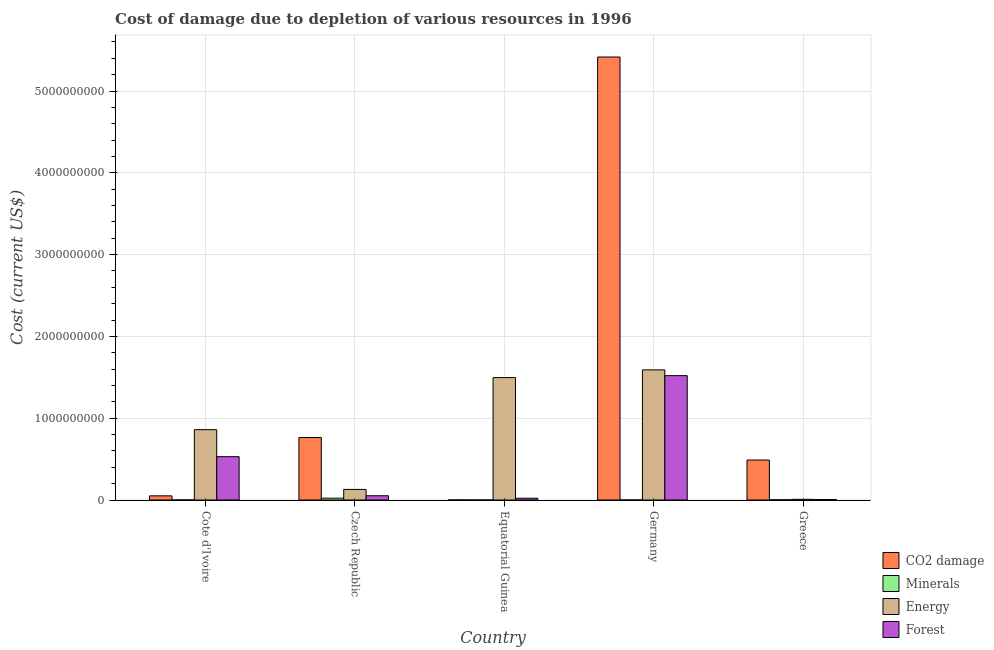Are the number of bars per tick equal to the number of legend labels?
Your response must be concise. Yes. How many bars are there on the 4th tick from the left?
Make the answer very short. 4. How many bars are there on the 1st tick from the right?
Your answer should be very brief. 4. What is the label of the 1st group of bars from the left?
Your answer should be compact. Cote d'Ivoire. In how many cases, is the number of bars for a given country not equal to the number of legend labels?
Your response must be concise. 0. What is the cost of damage due to depletion of minerals in Equatorial Guinea?
Provide a succinct answer. 5.43e+04. Across all countries, what is the maximum cost of damage due to depletion of forests?
Offer a terse response. 1.52e+09. Across all countries, what is the minimum cost of damage due to depletion of coal?
Keep it short and to the point. 7.14e+05. In which country was the cost of damage due to depletion of coal minimum?
Keep it short and to the point. Equatorial Guinea. What is the total cost of damage due to depletion of minerals in the graph?
Keep it short and to the point. 2.57e+07. What is the difference between the cost of damage due to depletion of minerals in Cote d'Ivoire and that in Greece?
Make the answer very short. -1.79e+06. What is the difference between the cost of damage due to depletion of forests in Cote d'Ivoire and the cost of damage due to depletion of minerals in Germany?
Your answer should be compact. 5.30e+08. What is the average cost of damage due to depletion of minerals per country?
Your response must be concise. 5.14e+06. What is the difference between the cost of damage due to depletion of energy and cost of damage due to depletion of forests in Cote d'Ivoire?
Provide a short and direct response. 3.30e+08. What is the ratio of the cost of damage due to depletion of forests in Cote d'Ivoire to that in Equatorial Guinea?
Give a very brief answer. 24.6. Is the cost of damage due to depletion of energy in Cote d'Ivoire less than that in Czech Republic?
Give a very brief answer. No. What is the difference between the highest and the second highest cost of damage due to depletion of energy?
Make the answer very short. 9.44e+07. What is the difference between the highest and the lowest cost of damage due to depletion of energy?
Give a very brief answer. 1.58e+09. Is the sum of the cost of damage due to depletion of energy in Czech Republic and Greece greater than the maximum cost of damage due to depletion of forests across all countries?
Offer a terse response. No. What does the 2nd bar from the left in Cote d'Ivoire represents?
Provide a short and direct response. Minerals. What does the 1st bar from the right in Equatorial Guinea represents?
Your answer should be compact. Forest. Is it the case that in every country, the sum of the cost of damage due to depletion of coal and cost of damage due to depletion of minerals is greater than the cost of damage due to depletion of energy?
Give a very brief answer. No. How many countries are there in the graph?
Offer a terse response. 5. What is the difference between two consecutive major ticks on the Y-axis?
Your answer should be very brief. 1.00e+09. Does the graph contain grids?
Your answer should be compact. Yes. How are the legend labels stacked?
Provide a short and direct response. Vertical. What is the title of the graph?
Offer a very short reply. Cost of damage due to depletion of various resources in 1996 . What is the label or title of the Y-axis?
Your answer should be very brief. Cost (current US$). What is the Cost (current US$) in CO2 damage in Cote d'Ivoire?
Keep it short and to the point. 5.10e+07. What is the Cost (current US$) in Minerals in Cote d'Ivoire?
Give a very brief answer. 7.40e+05. What is the Cost (current US$) in Energy in Cote d'Ivoire?
Offer a very short reply. 8.60e+08. What is the Cost (current US$) in Forest in Cote d'Ivoire?
Make the answer very short. 5.30e+08. What is the Cost (current US$) in CO2 damage in Czech Republic?
Your answer should be compact. 7.64e+08. What is the Cost (current US$) of Minerals in Czech Republic?
Keep it short and to the point. 2.23e+07. What is the Cost (current US$) of Energy in Czech Republic?
Your answer should be very brief. 1.29e+08. What is the Cost (current US$) of Forest in Czech Republic?
Your response must be concise. 5.21e+07. What is the Cost (current US$) of CO2 damage in Equatorial Guinea?
Keep it short and to the point. 7.14e+05. What is the Cost (current US$) in Minerals in Equatorial Guinea?
Make the answer very short. 5.43e+04. What is the Cost (current US$) in Energy in Equatorial Guinea?
Offer a very short reply. 1.50e+09. What is the Cost (current US$) of Forest in Equatorial Guinea?
Provide a succinct answer. 2.15e+07. What is the Cost (current US$) of CO2 damage in Germany?
Your answer should be very brief. 5.42e+09. What is the Cost (current US$) in Minerals in Germany?
Your answer should be compact. 7.40e+04. What is the Cost (current US$) of Energy in Germany?
Your answer should be very brief. 1.59e+09. What is the Cost (current US$) of Forest in Germany?
Give a very brief answer. 1.52e+09. What is the Cost (current US$) in CO2 damage in Greece?
Keep it short and to the point. 4.89e+08. What is the Cost (current US$) in Minerals in Greece?
Provide a succinct answer. 2.53e+06. What is the Cost (current US$) of Energy in Greece?
Keep it short and to the point. 8.16e+06. What is the Cost (current US$) in Forest in Greece?
Ensure brevity in your answer.  5.20e+06. Across all countries, what is the maximum Cost (current US$) of CO2 damage?
Your answer should be very brief. 5.42e+09. Across all countries, what is the maximum Cost (current US$) in Minerals?
Offer a terse response. 2.23e+07. Across all countries, what is the maximum Cost (current US$) in Energy?
Your answer should be very brief. 1.59e+09. Across all countries, what is the maximum Cost (current US$) of Forest?
Provide a succinct answer. 1.52e+09. Across all countries, what is the minimum Cost (current US$) of CO2 damage?
Ensure brevity in your answer.  7.14e+05. Across all countries, what is the minimum Cost (current US$) in Minerals?
Your response must be concise. 5.43e+04. Across all countries, what is the minimum Cost (current US$) of Energy?
Make the answer very short. 8.16e+06. Across all countries, what is the minimum Cost (current US$) of Forest?
Provide a short and direct response. 5.20e+06. What is the total Cost (current US$) in CO2 damage in the graph?
Keep it short and to the point. 6.72e+09. What is the total Cost (current US$) in Minerals in the graph?
Offer a very short reply. 2.57e+07. What is the total Cost (current US$) of Energy in the graph?
Provide a short and direct response. 4.09e+09. What is the total Cost (current US$) of Forest in the graph?
Your response must be concise. 2.13e+09. What is the difference between the Cost (current US$) of CO2 damage in Cote d'Ivoire and that in Czech Republic?
Give a very brief answer. -7.13e+08. What is the difference between the Cost (current US$) in Minerals in Cote d'Ivoire and that in Czech Republic?
Your response must be concise. -2.16e+07. What is the difference between the Cost (current US$) in Energy in Cote d'Ivoire and that in Czech Republic?
Give a very brief answer. 7.31e+08. What is the difference between the Cost (current US$) in Forest in Cote d'Ivoire and that in Czech Republic?
Your response must be concise. 4.78e+08. What is the difference between the Cost (current US$) in CO2 damage in Cote d'Ivoire and that in Equatorial Guinea?
Ensure brevity in your answer.  5.03e+07. What is the difference between the Cost (current US$) in Minerals in Cote d'Ivoire and that in Equatorial Guinea?
Your answer should be compact. 6.86e+05. What is the difference between the Cost (current US$) of Energy in Cote d'Ivoire and that in Equatorial Guinea?
Your answer should be very brief. -6.37e+08. What is the difference between the Cost (current US$) in Forest in Cote d'Ivoire and that in Equatorial Guinea?
Give a very brief answer. 5.08e+08. What is the difference between the Cost (current US$) of CO2 damage in Cote d'Ivoire and that in Germany?
Keep it short and to the point. -5.36e+09. What is the difference between the Cost (current US$) of Minerals in Cote d'Ivoire and that in Germany?
Offer a terse response. 6.66e+05. What is the difference between the Cost (current US$) in Energy in Cote d'Ivoire and that in Germany?
Give a very brief answer. -7.31e+08. What is the difference between the Cost (current US$) in Forest in Cote d'Ivoire and that in Germany?
Your answer should be compact. -9.91e+08. What is the difference between the Cost (current US$) in CO2 damage in Cote d'Ivoire and that in Greece?
Ensure brevity in your answer.  -4.37e+08. What is the difference between the Cost (current US$) of Minerals in Cote d'Ivoire and that in Greece?
Keep it short and to the point. -1.79e+06. What is the difference between the Cost (current US$) in Energy in Cote d'Ivoire and that in Greece?
Provide a succinct answer. 8.52e+08. What is the difference between the Cost (current US$) of Forest in Cote d'Ivoire and that in Greece?
Offer a very short reply. 5.24e+08. What is the difference between the Cost (current US$) of CO2 damage in Czech Republic and that in Equatorial Guinea?
Make the answer very short. 7.63e+08. What is the difference between the Cost (current US$) in Minerals in Czech Republic and that in Equatorial Guinea?
Ensure brevity in your answer.  2.23e+07. What is the difference between the Cost (current US$) of Energy in Czech Republic and that in Equatorial Guinea?
Provide a succinct answer. -1.37e+09. What is the difference between the Cost (current US$) of Forest in Czech Republic and that in Equatorial Guinea?
Make the answer very short. 3.06e+07. What is the difference between the Cost (current US$) of CO2 damage in Czech Republic and that in Germany?
Offer a very short reply. -4.65e+09. What is the difference between the Cost (current US$) in Minerals in Czech Republic and that in Germany?
Give a very brief answer. 2.22e+07. What is the difference between the Cost (current US$) of Energy in Czech Republic and that in Germany?
Provide a short and direct response. -1.46e+09. What is the difference between the Cost (current US$) in Forest in Czech Republic and that in Germany?
Offer a terse response. -1.47e+09. What is the difference between the Cost (current US$) in CO2 damage in Czech Republic and that in Greece?
Offer a terse response. 2.75e+08. What is the difference between the Cost (current US$) of Minerals in Czech Republic and that in Greece?
Offer a very short reply. 1.98e+07. What is the difference between the Cost (current US$) of Energy in Czech Republic and that in Greece?
Offer a terse response. 1.21e+08. What is the difference between the Cost (current US$) in Forest in Czech Republic and that in Greece?
Ensure brevity in your answer.  4.69e+07. What is the difference between the Cost (current US$) in CO2 damage in Equatorial Guinea and that in Germany?
Keep it short and to the point. -5.42e+09. What is the difference between the Cost (current US$) of Minerals in Equatorial Guinea and that in Germany?
Ensure brevity in your answer.  -1.97e+04. What is the difference between the Cost (current US$) of Energy in Equatorial Guinea and that in Germany?
Give a very brief answer. -9.44e+07. What is the difference between the Cost (current US$) in Forest in Equatorial Guinea and that in Germany?
Make the answer very short. -1.50e+09. What is the difference between the Cost (current US$) in CO2 damage in Equatorial Guinea and that in Greece?
Provide a succinct answer. -4.88e+08. What is the difference between the Cost (current US$) of Minerals in Equatorial Guinea and that in Greece?
Provide a short and direct response. -2.48e+06. What is the difference between the Cost (current US$) of Energy in Equatorial Guinea and that in Greece?
Provide a succinct answer. 1.49e+09. What is the difference between the Cost (current US$) of Forest in Equatorial Guinea and that in Greece?
Offer a very short reply. 1.63e+07. What is the difference between the Cost (current US$) in CO2 damage in Germany and that in Greece?
Offer a very short reply. 4.93e+09. What is the difference between the Cost (current US$) in Minerals in Germany and that in Greece?
Keep it short and to the point. -2.46e+06. What is the difference between the Cost (current US$) in Energy in Germany and that in Greece?
Ensure brevity in your answer.  1.58e+09. What is the difference between the Cost (current US$) in Forest in Germany and that in Greece?
Ensure brevity in your answer.  1.52e+09. What is the difference between the Cost (current US$) of CO2 damage in Cote d'Ivoire and the Cost (current US$) of Minerals in Czech Republic?
Your answer should be compact. 2.87e+07. What is the difference between the Cost (current US$) in CO2 damage in Cote d'Ivoire and the Cost (current US$) in Energy in Czech Republic?
Your answer should be very brief. -7.84e+07. What is the difference between the Cost (current US$) in CO2 damage in Cote d'Ivoire and the Cost (current US$) in Forest in Czech Republic?
Provide a succinct answer. -1.10e+06. What is the difference between the Cost (current US$) of Minerals in Cote d'Ivoire and the Cost (current US$) of Energy in Czech Republic?
Your answer should be very brief. -1.29e+08. What is the difference between the Cost (current US$) in Minerals in Cote d'Ivoire and the Cost (current US$) in Forest in Czech Republic?
Your answer should be very brief. -5.14e+07. What is the difference between the Cost (current US$) of Energy in Cote d'Ivoire and the Cost (current US$) of Forest in Czech Republic?
Offer a terse response. 8.08e+08. What is the difference between the Cost (current US$) in CO2 damage in Cote d'Ivoire and the Cost (current US$) in Minerals in Equatorial Guinea?
Keep it short and to the point. 5.10e+07. What is the difference between the Cost (current US$) of CO2 damage in Cote d'Ivoire and the Cost (current US$) of Energy in Equatorial Guinea?
Ensure brevity in your answer.  -1.45e+09. What is the difference between the Cost (current US$) of CO2 damage in Cote d'Ivoire and the Cost (current US$) of Forest in Equatorial Guinea?
Your response must be concise. 2.95e+07. What is the difference between the Cost (current US$) in Minerals in Cote d'Ivoire and the Cost (current US$) in Energy in Equatorial Guinea?
Ensure brevity in your answer.  -1.50e+09. What is the difference between the Cost (current US$) of Minerals in Cote d'Ivoire and the Cost (current US$) of Forest in Equatorial Guinea?
Your answer should be compact. -2.08e+07. What is the difference between the Cost (current US$) in Energy in Cote d'Ivoire and the Cost (current US$) in Forest in Equatorial Guinea?
Your answer should be compact. 8.39e+08. What is the difference between the Cost (current US$) in CO2 damage in Cote d'Ivoire and the Cost (current US$) in Minerals in Germany?
Make the answer very short. 5.09e+07. What is the difference between the Cost (current US$) in CO2 damage in Cote d'Ivoire and the Cost (current US$) in Energy in Germany?
Keep it short and to the point. -1.54e+09. What is the difference between the Cost (current US$) of CO2 damage in Cote d'Ivoire and the Cost (current US$) of Forest in Germany?
Your answer should be very brief. -1.47e+09. What is the difference between the Cost (current US$) in Minerals in Cote d'Ivoire and the Cost (current US$) in Energy in Germany?
Offer a terse response. -1.59e+09. What is the difference between the Cost (current US$) in Minerals in Cote d'Ivoire and the Cost (current US$) in Forest in Germany?
Make the answer very short. -1.52e+09. What is the difference between the Cost (current US$) in Energy in Cote d'Ivoire and the Cost (current US$) in Forest in Germany?
Your answer should be compact. -6.60e+08. What is the difference between the Cost (current US$) in CO2 damage in Cote d'Ivoire and the Cost (current US$) in Minerals in Greece?
Your answer should be very brief. 4.85e+07. What is the difference between the Cost (current US$) in CO2 damage in Cote d'Ivoire and the Cost (current US$) in Energy in Greece?
Offer a very short reply. 4.29e+07. What is the difference between the Cost (current US$) of CO2 damage in Cote d'Ivoire and the Cost (current US$) of Forest in Greece?
Your answer should be compact. 4.58e+07. What is the difference between the Cost (current US$) of Minerals in Cote d'Ivoire and the Cost (current US$) of Energy in Greece?
Provide a short and direct response. -7.42e+06. What is the difference between the Cost (current US$) of Minerals in Cote d'Ivoire and the Cost (current US$) of Forest in Greece?
Keep it short and to the point. -4.46e+06. What is the difference between the Cost (current US$) in Energy in Cote d'Ivoire and the Cost (current US$) in Forest in Greece?
Provide a succinct answer. 8.55e+08. What is the difference between the Cost (current US$) of CO2 damage in Czech Republic and the Cost (current US$) of Minerals in Equatorial Guinea?
Make the answer very short. 7.64e+08. What is the difference between the Cost (current US$) in CO2 damage in Czech Republic and the Cost (current US$) in Energy in Equatorial Guinea?
Offer a terse response. -7.33e+08. What is the difference between the Cost (current US$) in CO2 damage in Czech Republic and the Cost (current US$) in Forest in Equatorial Guinea?
Offer a terse response. 7.42e+08. What is the difference between the Cost (current US$) in Minerals in Czech Republic and the Cost (current US$) in Energy in Equatorial Guinea?
Give a very brief answer. -1.47e+09. What is the difference between the Cost (current US$) in Minerals in Czech Republic and the Cost (current US$) in Forest in Equatorial Guinea?
Ensure brevity in your answer.  7.80e+05. What is the difference between the Cost (current US$) of Energy in Czech Republic and the Cost (current US$) of Forest in Equatorial Guinea?
Offer a very short reply. 1.08e+08. What is the difference between the Cost (current US$) in CO2 damage in Czech Republic and the Cost (current US$) in Minerals in Germany?
Provide a succinct answer. 7.64e+08. What is the difference between the Cost (current US$) of CO2 damage in Czech Republic and the Cost (current US$) of Energy in Germany?
Provide a succinct answer. -8.27e+08. What is the difference between the Cost (current US$) of CO2 damage in Czech Republic and the Cost (current US$) of Forest in Germany?
Give a very brief answer. -7.56e+08. What is the difference between the Cost (current US$) in Minerals in Czech Republic and the Cost (current US$) in Energy in Germany?
Offer a terse response. -1.57e+09. What is the difference between the Cost (current US$) in Minerals in Czech Republic and the Cost (current US$) in Forest in Germany?
Keep it short and to the point. -1.50e+09. What is the difference between the Cost (current US$) of Energy in Czech Republic and the Cost (current US$) of Forest in Germany?
Provide a short and direct response. -1.39e+09. What is the difference between the Cost (current US$) of CO2 damage in Czech Republic and the Cost (current US$) of Minerals in Greece?
Ensure brevity in your answer.  7.61e+08. What is the difference between the Cost (current US$) of CO2 damage in Czech Republic and the Cost (current US$) of Energy in Greece?
Make the answer very short. 7.56e+08. What is the difference between the Cost (current US$) in CO2 damage in Czech Republic and the Cost (current US$) in Forest in Greece?
Make the answer very short. 7.59e+08. What is the difference between the Cost (current US$) in Minerals in Czech Republic and the Cost (current US$) in Energy in Greece?
Your response must be concise. 1.42e+07. What is the difference between the Cost (current US$) of Minerals in Czech Republic and the Cost (current US$) of Forest in Greece?
Make the answer very short. 1.71e+07. What is the difference between the Cost (current US$) in Energy in Czech Republic and the Cost (current US$) in Forest in Greece?
Your response must be concise. 1.24e+08. What is the difference between the Cost (current US$) of CO2 damage in Equatorial Guinea and the Cost (current US$) of Minerals in Germany?
Your response must be concise. 6.40e+05. What is the difference between the Cost (current US$) in CO2 damage in Equatorial Guinea and the Cost (current US$) in Energy in Germany?
Your answer should be compact. -1.59e+09. What is the difference between the Cost (current US$) in CO2 damage in Equatorial Guinea and the Cost (current US$) in Forest in Germany?
Make the answer very short. -1.52e+09. What is the difference between the Cost (current US$) of Minerals in Equatorial Guinea and the Cost (current US$) of Energy in Germany?
Make the answer very short. -1.59e+09. What is the difference between the Cost (current US$) in Minerals in Equatorial Guinea and the Cost (current US$) in Forest in Germany?
Your answer should be very brief. -1.52e+09. What is the difference between the Cost (current US$) in Energy in Equatorial Guinea and the Cost (current US$) in Forest in Germany?
Provide a short and direct response. -2.37e+07. What is the difference between the Cost (current US$) of CO2 damage in Equatorial Guinea and the Cost (current US$) of Minerals in Greece?
Offer a very short reply. -1.82e+06. What is the difference between the Cost (current US$) in CO2 damage in Equatorial Guinea and the Cost (current US$) in Energy in Greece?
Give a very brief answer. -7.45e+06. What is the difference between the Cost (current US$) in CO2 damage in Equatorial Guinea and the Cost (current US$) in Forest in Greece?
Your response must be concise. -4.48e+06. What is the difference between the Cost (current US$) of Minerals in Equatorial Guinea and the Cost (current US$) of Energy in Greece?
Give a very brief answer. -8.11e+06. What is the difference between the Cost (current US$) in Minerals in Equatorial Guinea and the Cost (current US$) in Forest in Greece?
Offer a terse response. -5.14e+06. What is the difference between the Cost (current US$) in Energy in Equatorial Guinea and the Cost (current US$) in Forest in Greece?
Provide a short and direct response. 1.49e+09. What is the difference between the Cost (current US$) in CO2 damage in Germany and the Cost (current US$) in Minerals in Greece?
Give a very brief answer. 5.41e+09. What is the difference between the Cost (current US$) of CO2 damage in Germany and the Cost (current US$) of Energy in Greece?
Make the answer very short. 5.41e+09. What is the difference between the Cost (current US$) in CO2 damage in Germany and the Cost (current US$) in Forest in Greece?
Keep it short and to the point. 5.41e+09. What is the difference between the Cost (current US$) of Minerals in Germany and the Cost (current US$) of Energy in Greece?
Provide a succinct answer. -8.09e+06. What is the difference between the Cost (current US$) in Minerals in Germany and the Cost (current US$) in Forest in Greece?
Keep it short and to the point. -5.12e+06. What is the difference between the Cost (current US$) of Energy in Germany and the Cost (current US$) of Forest in Greece?
Give a very brief answer. 1.59e+09. What is the average Cost (current US$) of CO2 damage per country?
Make the answer very short. 1.34e+09. What is the average Cost (current US$) of Minerals per country?
Your answer should be very brief. 5.14e+06. What is the average Cost (current US$) of Energy per country?
Give a very brief answer. 8.17e+08. What is the average Cost (current US$) of Forest per country?
Your answer should be compact. 4.26e+08. What is the difference between the Cost (current US$) of CO2 damage and Cost (current US$) of Minerals in Cote d'Ivoire?
Offer a very short reply. 5.03e+07. What is the difference between the Cost (current US$) in CO2 damage and Cost (current US$) in Energy in Cote d'Ivoire?
Give a very brief answer. -8.09e+08. What is the difference between the Cost (current US$) in CO2 damage and Cost (current US$) in Forest in Cote d'Ivoire?
Provide a succinct answer. -4.79e+08. What is the difference between the Cost (current US$) in Minerals and Cost (current US$) in Energy in Cote d'Ivoire?
Make the answer very short. -8.59e+08. What is the difference between the Cost (current US$) of Minerals and Cost (current US$) of Forest in Cote d'Ivoire?
Keep it short and to the point. -5.29e+08. What is the difference between the Cost (current US$) in Energy and Cost (current US$) in Forest in Cote d'Ivoire?
Offer a terse response. 3.30e+08. What is the difference between the Cost (current US$) in CO2 damage and Cost (current US$) in Minerals in Czech Republic?
Your answer should be compact. 7.42e+08. What is the difference between the Cost (current US$) in CO2 damage and Cost (current US$) in Energy in Czech Republic?
Offer a very short reply. 6.34e+08. What is the difference between the Cost (current US$) of CO2 damage and Cost (current US$) of Forest in Czech Republic?
Keep it short and to the point. 7.12e+08. What is the difference between the Cost (current US$) in Minerals and Cost (current US$) in Energy in Czech Republic?
Ensure brevity in your answer.  -1.07e+08. What is the difference between the Cost (current US$) of Minerals and Cost (current US$) of Forest in Czech Republic?
Give a very brief answer. -2.98e+07. What is the difference between the Cost (current US$) of Energy and Cost (current US$) of Forest in Czech Republic?
Give a very brief answer. 7.74e+07. What is the difference between the Cost (current US$) in CO2 damage and Cost (current US$) in Minerals in Equatorial Guinea?
Your answer should be compact. 6.60e+05. What is the difference between the Cost (current US$) of CO2 damage and Cost (current US$) of Energy in Equatorial Guinea?
Provide a short and direct response. -1.50e+09. What is the difference between the Cost (current US$) of CO2 damage and Cost (current US$) of Forest in Equatorial Guinea?
Offer a terse response. -2.08e+07. What is the difference between the Cost (current US$) of Minerals and Cost (current US$) of Energy in Equatorial Guinea?
Offer a terse response. -1.50e+09. What is the difference between the Cost (current US$) of Minerals and Cost (current US$) of Forest in Equatorial Guinea?
Ensure brevity in your answer.  -2.15e+07. What is the difference between the Cost (current US$) of Energy and Cost (current US$) of Forest in Equatorial Guinea?
Ensure brevity in your answer.  1.48e+09. What is the difference between the Cost (current US$) in CO2 damage and Cost (current US$) in Minerals in Germany?
Provide a short and direct response. 5.42e+09. What is the difference between the Cost (current US$) in CO2 damage and Cost (current US$) in Energy in Germany?
Your answer should be very brief. 3.82e+09. What is the difference between the Cost (current US$) of CO2 damage and Cost (current US$) of Forest in Germany?
Provide a short and direct response. 3.90e+09. What is the difference between the Cost (current US$) in Minerals and Cost (current US$) in Energy in Germany?
Ensure brevity in your answer.  -1.59e+09. What is the difference between the Cost (current US$) of Minerals and Cost (current US$) of Forest in Germany?
Keep it short and to the point. -1.52e+09. What is the difference between the Cost (current US$) of Energy and Cost (current US$) of Forest in Germany?
Give a very brief answer. 7.07e+07. What is the difference between the Cost (current US$) of CO2 damage and Cost (current US$) of Minerals in Greece?
Make the answer very short. 4.86e+08. What is the difference between the Cost (current US$) in CO2 damage and Cost (current US$) in Energy in Greece?
Ensure brevity in your answer.  4.80e+08. What is the difference between the Cost (current US$) of CO2 damage and Cost (current US$) of Forest in Greece?
Offer a terse response. 4.83e+08. What is the difference between the Cost (current US$) of Minerals and Cost (current US$) of Energy in Greece?
Keep it short and to the point. -5.62e+06. What is the difference between the Cost (current US$) of Minerals and Cost (current US$) of Forest in Greece?
Make the answer very short. -2.66e+06. What is the difference between the Cost (current US$) in Energy and Cost (current US$) in Forest in Greece?
Make the answer very short. 2.96e+06. What is the ratio of the Cost (current US$) in CO2 damage in Cote d'Ivoire to that in Czech Republic?
Your answer should be very brief. 0.07. What is the ratio of the Cost (current US$) of Minerals in Cote d'Ivoire to that in Czech Republic?
Give a very brief answer. 0.03. What is the ratio of the Cost (current US$) of Energy in Cote d'Ivoire to that in Czech Republic?
Provide a short and direct response. 6.64. What is the ratio of the Cost (current US$) in Forest in Cote d'Ivoire to that in Czech Republic?
Offer a very short reply. 10.17. What is the ratio of the Cost (current US$) of CO2 damage in Cote d'Ivoire to that in Equatorial Guinea?
Your answer should be compact. 71.41. What is the ratio of the Cost (current US$) in Minerals in Cote d'Ivoire to that in Equatorial Guinea?
Ensure brevity in your answer.  13.63. What is the ratio of the Cost (current US$) of Energy in Cote d'Ivoire to that in Equatorial Guinea?
Keep it short and to the point. 0.57. What is the ratio of the Cost (current US$) in Forest in Cote d'Ivoire to that in Equatorial Guinea?
Keep it short and to the point. 24.6. What is the ratio of the Cost (current US$) in CO2 damage in Cote d'Ivoire to that in Germany?
Give a very brief answer. 0.01. What is the ratio of the Cost (current US$) in Minerals in Cote d'Ivoire to that in Germany?
Make the answer very short. 10. What is the ratio of the Cost (current US$) in Energy in Cote d'Ivoire to that in Germany?
Offer a very short reply. 0.54. What is the ratio of the Cost (current US$) of Forest in Cote d'Ivoire to that in Germany?
Keep it short and to the point. 0.35. What is the ratio of the Cost (current US$) of CO2 damage in Cote d'Ivoire to that in Greece?
Offer a terse response. 0.1. What is the ratio of the Cost (current US$) of Minerals in Cote d'Ivoire to that in Greece?
Keep it short and to the point. 0.29. What is the ratio of the Cost (current US$) in Energy in Cote d'Ivoire to that in Greece?
Keep it short and to the point. 105.4. What is the ratio of the Cost (current US$) of Forest in Cote d'Ivoire to that in Greece?
Provide a succinct answer. 101.94. What is the ratio of the Cost (current US$) of CO2 damage in Czech Republic to that in Equatorial Guinea?
Ensure brevity in your answer.  1069.25. What is the ratio of the Cost (current US$) of Minerals in Czech Republic to that in Equatorial Guinea?
Your response must be concise. 410.71. What is the ratio of the Cost (current US$) of Energy in Czech Republic to that in Equatorial Guinea?
Your answer should be very brief. 0.09. What is the ratio of the Cost (current US$) in Forest in Czech Republic to that in Equatorial Guinea?
Give a very brief answer. 2.42. What is the ratio of the Cost (current US$) of CO2 damage in Czech Republic to that in Germany?
Keep it short and to the point. 0.14. What is the ratio of the Cost (current US$) in Minerals in Czech Republic to that in Germany?
Ensure brevity in your answer.  301.39. What is the ratio of the Cost (current US$) in Energy in Czech Republic to that in Germany?
Ensure brevity in your answer.  0.08. What is the ratio of the Cost (current US$) in Forest in Czech Republic to that in Germany?
Your answer should be very brief. 0.03. What is the ratio of the Cost (current US$) in CO2 damage in Czech Republic to that in Greece?
Your answer should be compact. 1.56. What is the ratio of the Cost (current US$) of Minerals in Czech Republic to that in Greece?
Make the answer very short. 8.8. What is the ratio of the Cost (current US$) in Energy in Czech Republic to that in Greece?
Ensure brevity in your answer.  15.87. What is the ratio of the Cost (current US$) of Forest in Czech Republic to that in Greece?
Your response must be concise. 10.03. What is the ratio of the Cost (current US$) in CO2 damage in Equatorial Guinea to that in Germany?
Keep it short and to the point. 0. What is the ratio of the Cost (current US$) in Minerals in Equatorial Guinea to that in Germany?
Provide a succinct answer. 0.73. What is the ratio of the Cost (current US$) in Energy in Equatorial Guinea to that in Germany?
Your answer should be very brief. 0.94. What is the ratio of the Cost (current US$) in Forest in Equatorial Guinea to that in Germany?
Offer a very short reply. 0.01. What is the ratio of the Cost (current US$) of CO2 damage in Equatorial Guinea to that in Greece?
Your answer should be very brief. 0. What is the ratio of the Cost (current US$) in Minerals in Equatorial Guinea to that in Greece?
Make the answer very short. 0.02. What is the ratio of the Cost (current US$) in Energy in Equatorial Guinea to that in Greece?
Your answer should be compact. 183.43. What is the ratio of the Cost (current US$) in Forest in Equatorial Guinea to that in Greece?
Give a very brief answer. 4.14. What is the ratio of the Cost (current US$) of CO2 damage in Germany to that in Greece?
Provide a succinct answer. 11.09. What is the ratio of the Cost (current US$) of Minerals in Germany to that in Greece?
Offer a very short reply. 0.03. What is the ratio of the Cost (current US$) of Energy in Germany to that in Greece?
Provide a short and direct response. 195. What is the ratio of the Cost (current US$) of Forest in Germany to that in Greece?
Make the answer very short. 292.58. What is the difference between the highest and the second highest Cost (current US$) in CO2 damage?
Make the answer very short. 4.65e+09. What is the difference between the highest and the second highest Cost (current US$) of Minerals?
Offer a terse response. 1.98e+07. What is the difference between the highest and the second highest Cost (current US$) in Energy?
Offer a terse response. 9.44e+07. What is the difference between the highest and the second highest Cost (current US$) of Forest?
Your answer should be compact. 9.91e+08. What is the difference between the highest and the lowest Cost (current US$) of CO2 damage?
Your answer should be very brief. 5.42e+09. What is the difference between the highest and the lowest Cost (current US$) of Minerals?
Offer a terse response. 2.23e+07. What is the difference between the highest and the lowest Cost (current US$) in Energy?
Ensure brevity in your answer.  1.58e+09. What is the difference between the highest and the lowest Cost (current US$) in Forest?
Make the answer very short. 1.52e+09. 